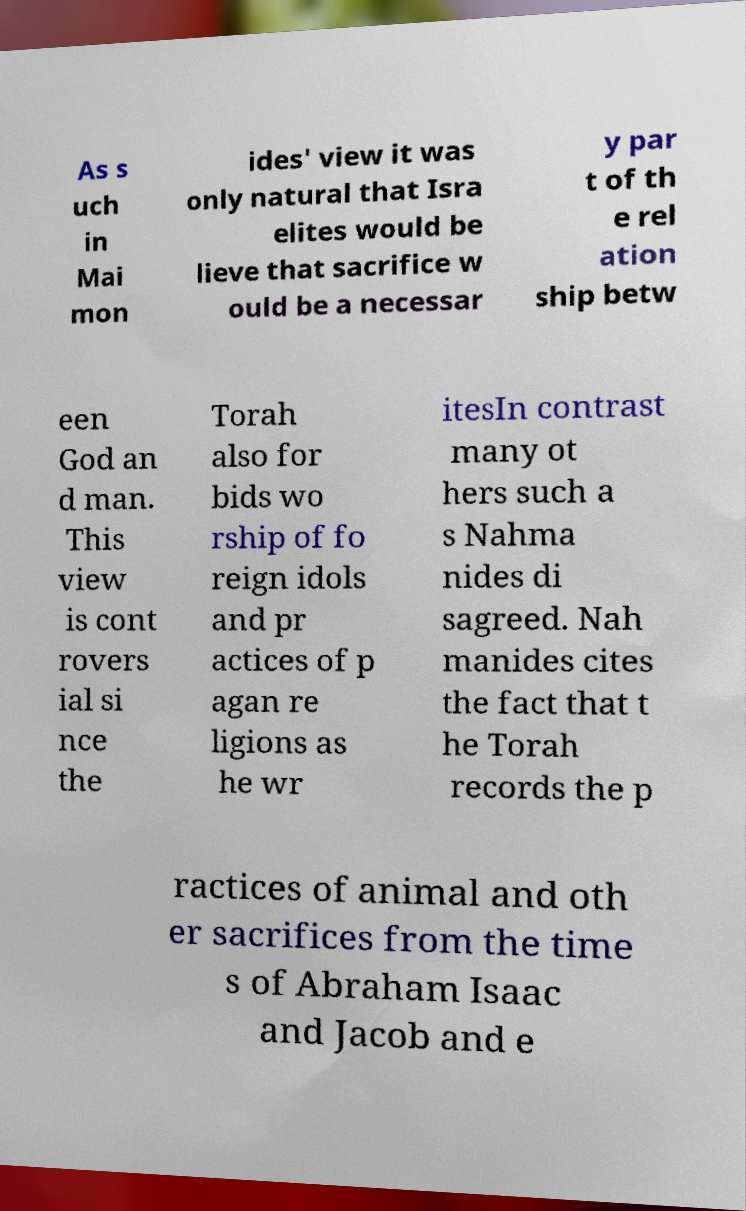Could you extract and type out the text from this image? As s uch in Mai mon ides' view it was only natural that Isra elites would be lieve that sacrifice w ould be a necessar y par t of th e rel ation ship betw een God an d man. This view is cont rovers ial si nce the Torah also for bids wo rship of fo reign idols and pr actices of p agan re ligions as he wr itesIn contrast many ot hers such a s Nahma nides di sagreed. Nah manides cites the fact that t he Torah records the p ractices of animal and oth er sacrifices from the time s of Abraham Isaac and Jacob and e 